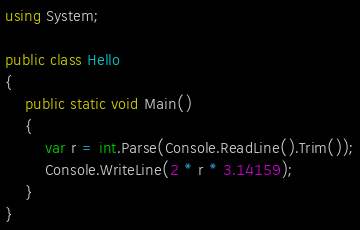Convert code to text. <code><loc_0><loc_0><loc_500><loc_500><_C#_>using System;

public class Hello
{
    public static void Main()
    {
        var r = int.Parse(Console.ReadLine().Trim());
        Console.WriteLine(2 * r * 3.14159);
    }
}
</code> 